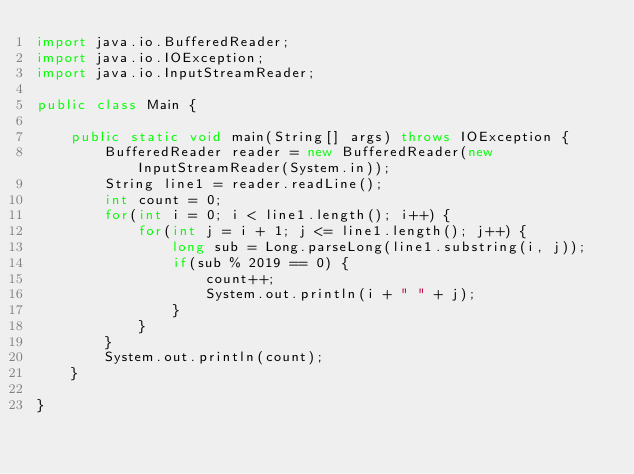<code> <loc_0><loc_0><loc_500><loc_500><_Java_>import java.io.BufferedReader;
import java.io.IOException;
import java.io.InputStreamReader;

public class Main {
	
	public static void main(String[] args) throws IOException {
		BufferedReader reader = new BufferedReader(new InputStreamReader(System.in));
		String line1 = reader.readLine();
		int count = 0;
		for(int i = 0; i < line1.length(); i++) {
			for(int j = i + 1; j <= line1.length(); j++) {
				long sub = Long.parseLong(line1.substring(i, j));
				if(sub % 2019 == 0) {
					count++;
					System.out.println(i + " " + j);
				}
			}
		}
		System.out.println(count);
	}

}
</code> 